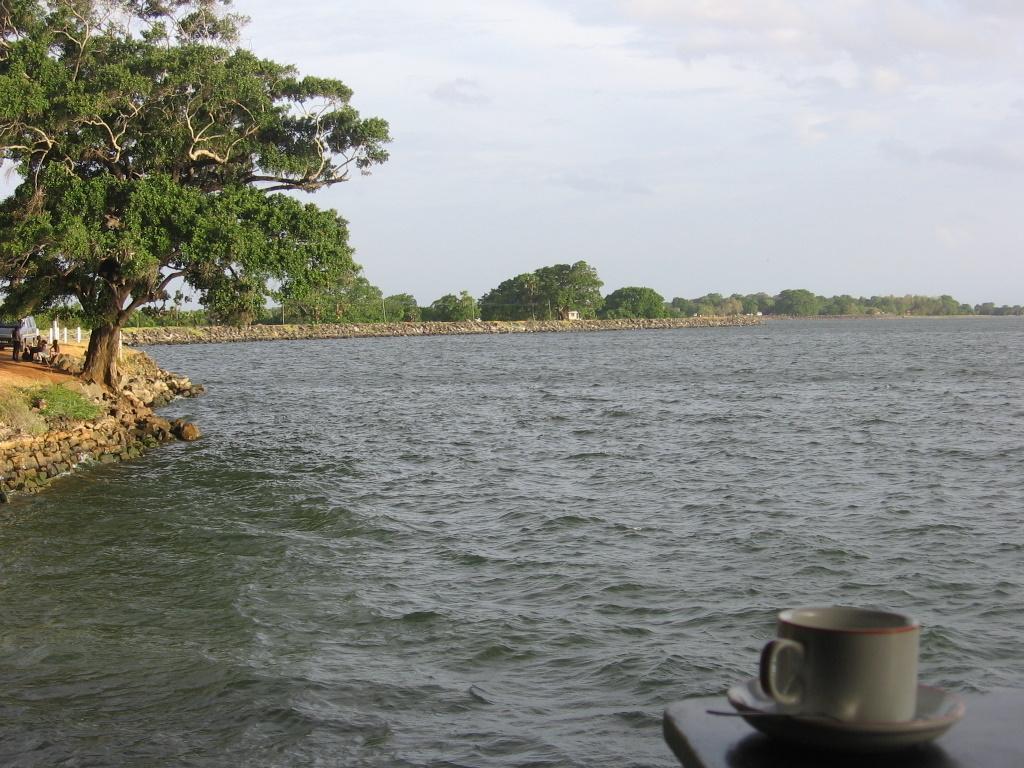Can you describe this image briefly? In this picture I can see the lake. On the left I can see the trees, plants and grass. In the bottom right corner I can see the cup, saucer and spoon which are kept on the table. At the top I can see the sky and clouds. 